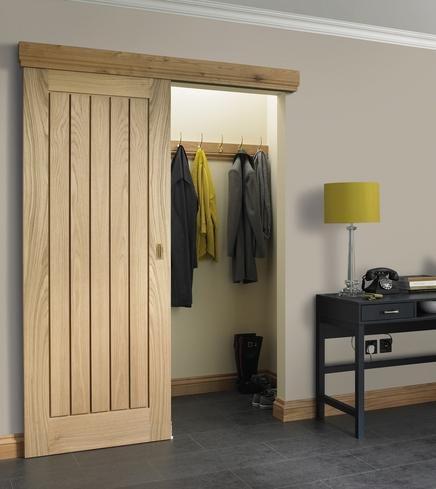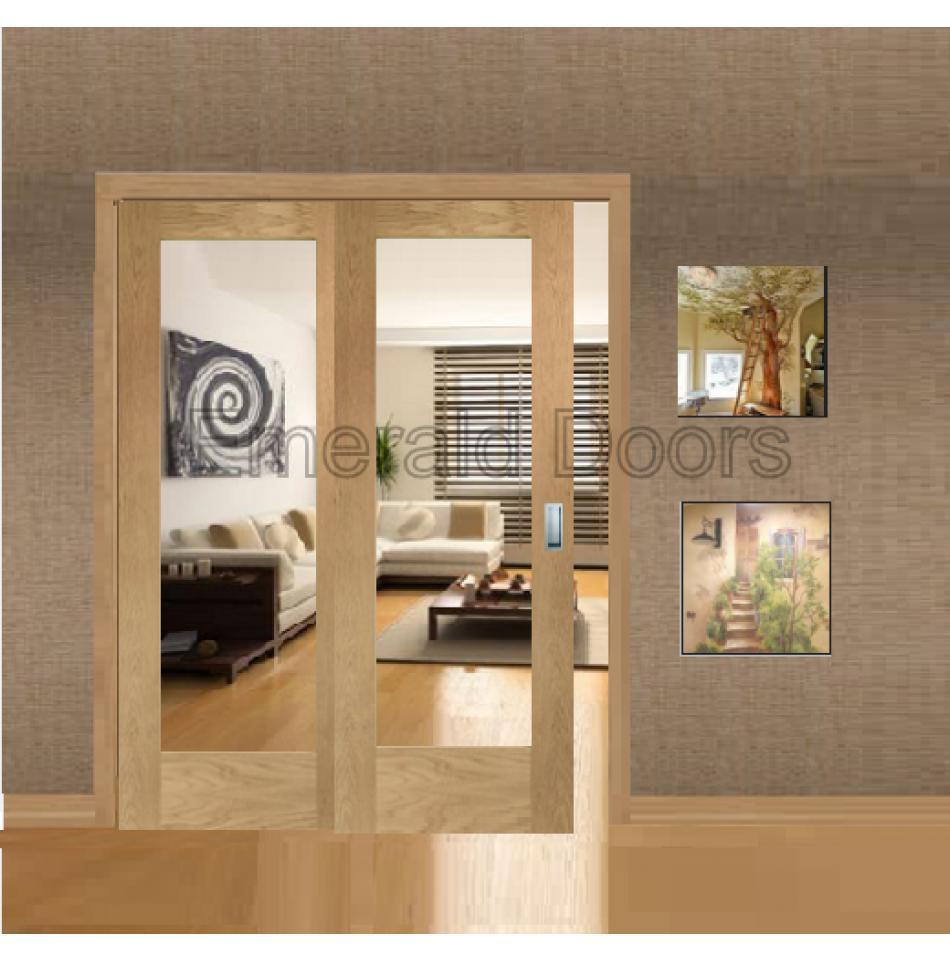The first image is the image on the left, the second image is the image on the right. Assess this claim about the two images: "An image shows a white-framed sliding door partly opened on the right, revealing a square framed item on the wall.". Correct or not? Answer yes or no. No. The first image is the image on the left, the second image is the image on the right. Examine the images to the left and right. Is the description "Each image shows equal sized white double sliding doors with decorative panels, with one door with visible hardware partially opened." accurate? Answer yes or no. No. 